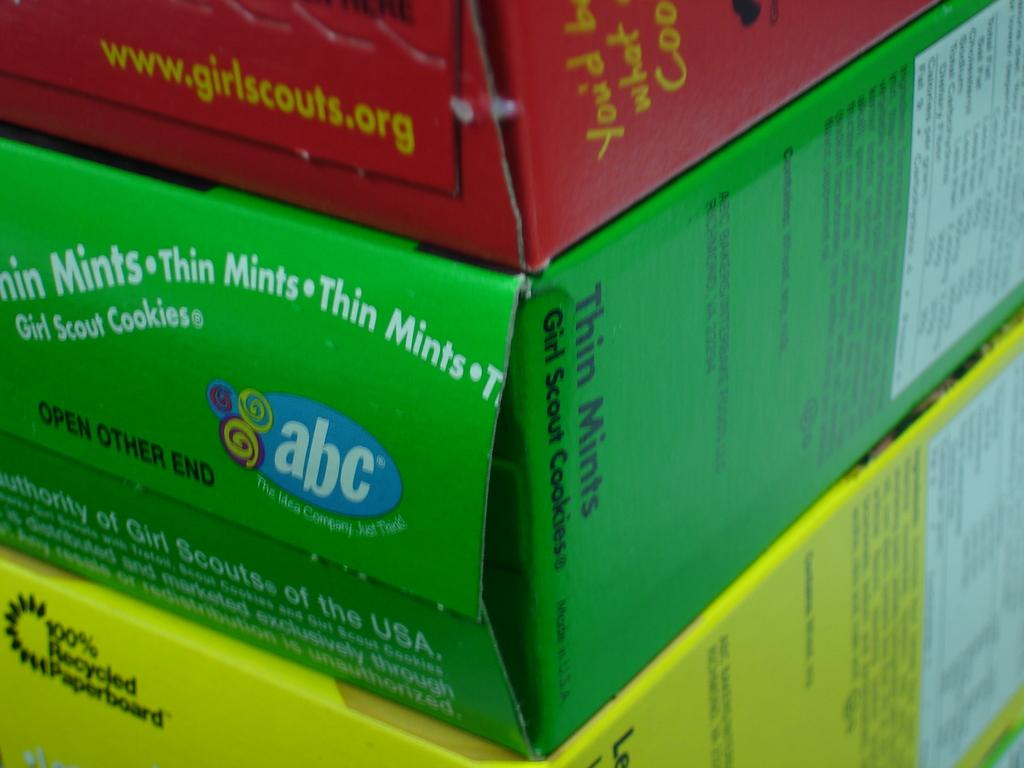<image>
Create a compact narrative representing the image presented. A green box says to open at other end. 